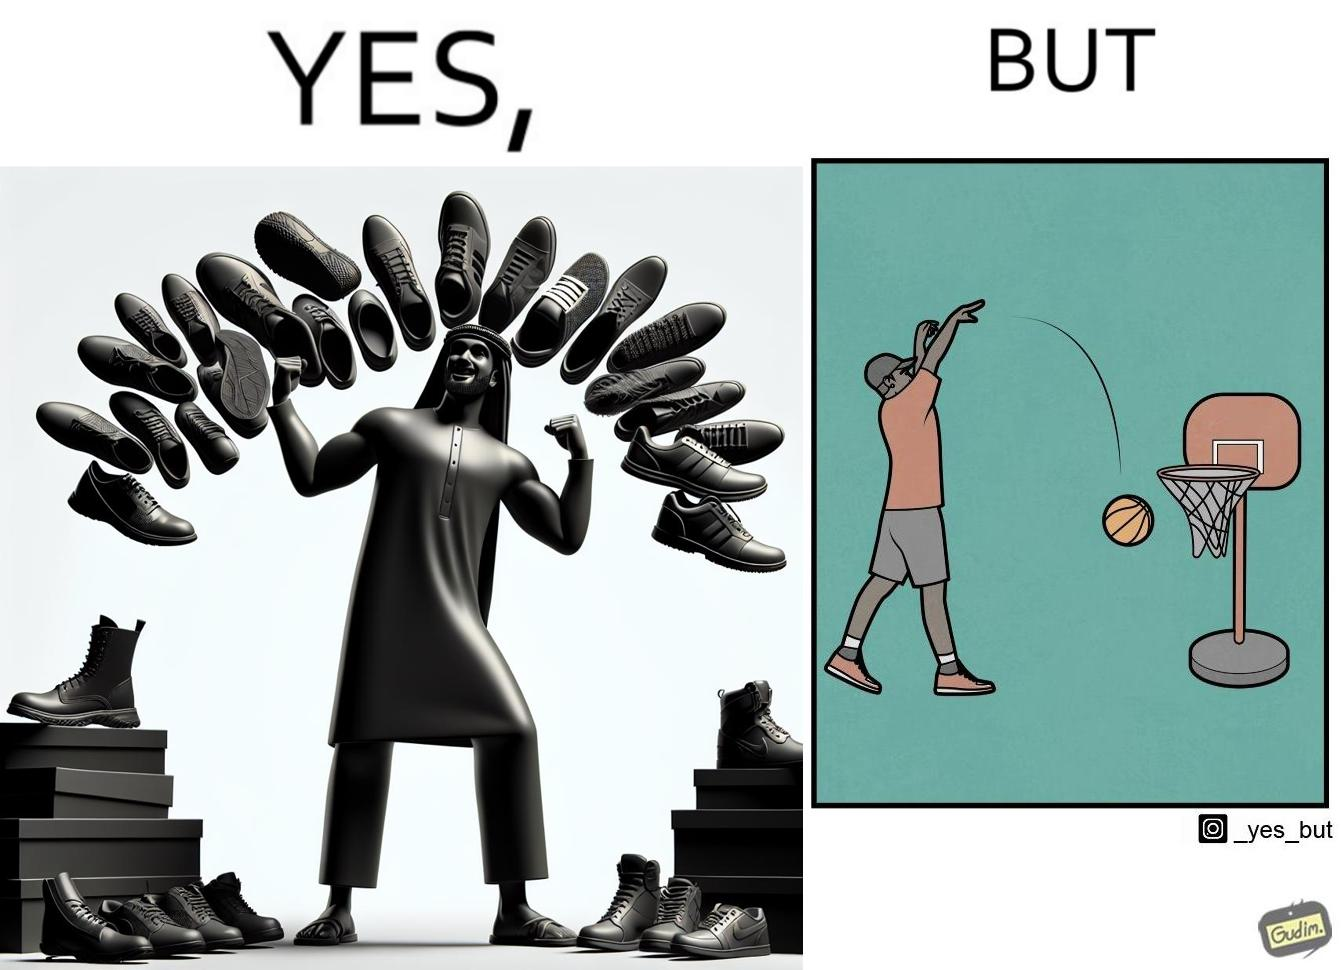Is this image satirical or non-satirical? Yes, this image is satirical. 